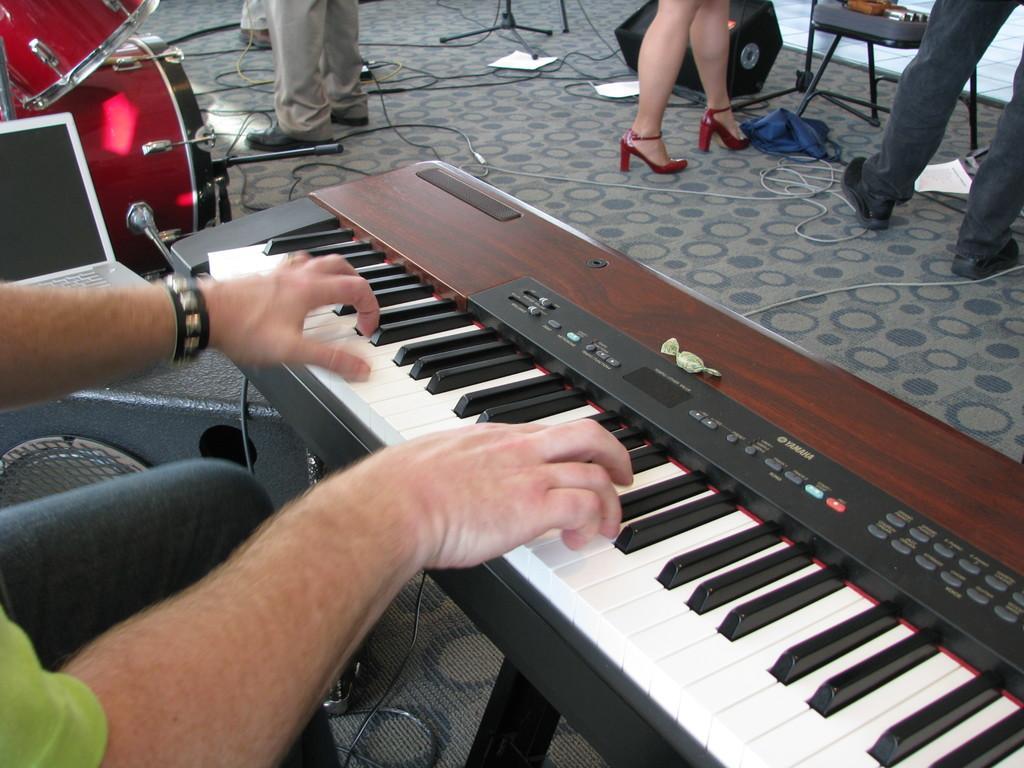Describe this image in one or two sentences. In this picture we can see some person is playing piano and beside to him we can see laptop, drums, were, some person standing, cloth, papers, speakers and chair and we have chocolate on piano. 